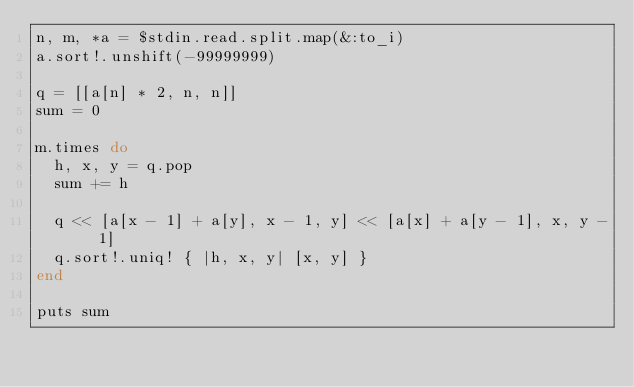Convert code to text. <code><loc_0><loc_0><loc_500><loc_500><_Ruby_>n, m, *a = $stdin.read.split.map(&:to_i)
a.sort!.unshift(-99999999)

q = [[a[n] * 2, n, n]]
sum = 0

m.times do
  h, x, y = q.pop
  sum += h
  
  q << [a[x - 1] + a[y], x - 1, y] << [a[x] + a[y - 1], x, y - 1]
  q.sort!.uniq! { |h, x, y| [x, y] }
end

puts sum
</code> 